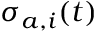Convert formula to latex. <formula><loc_0><loc_0><loc_500><loc_500>\sigma _ { a , i } ( t )</formula> 